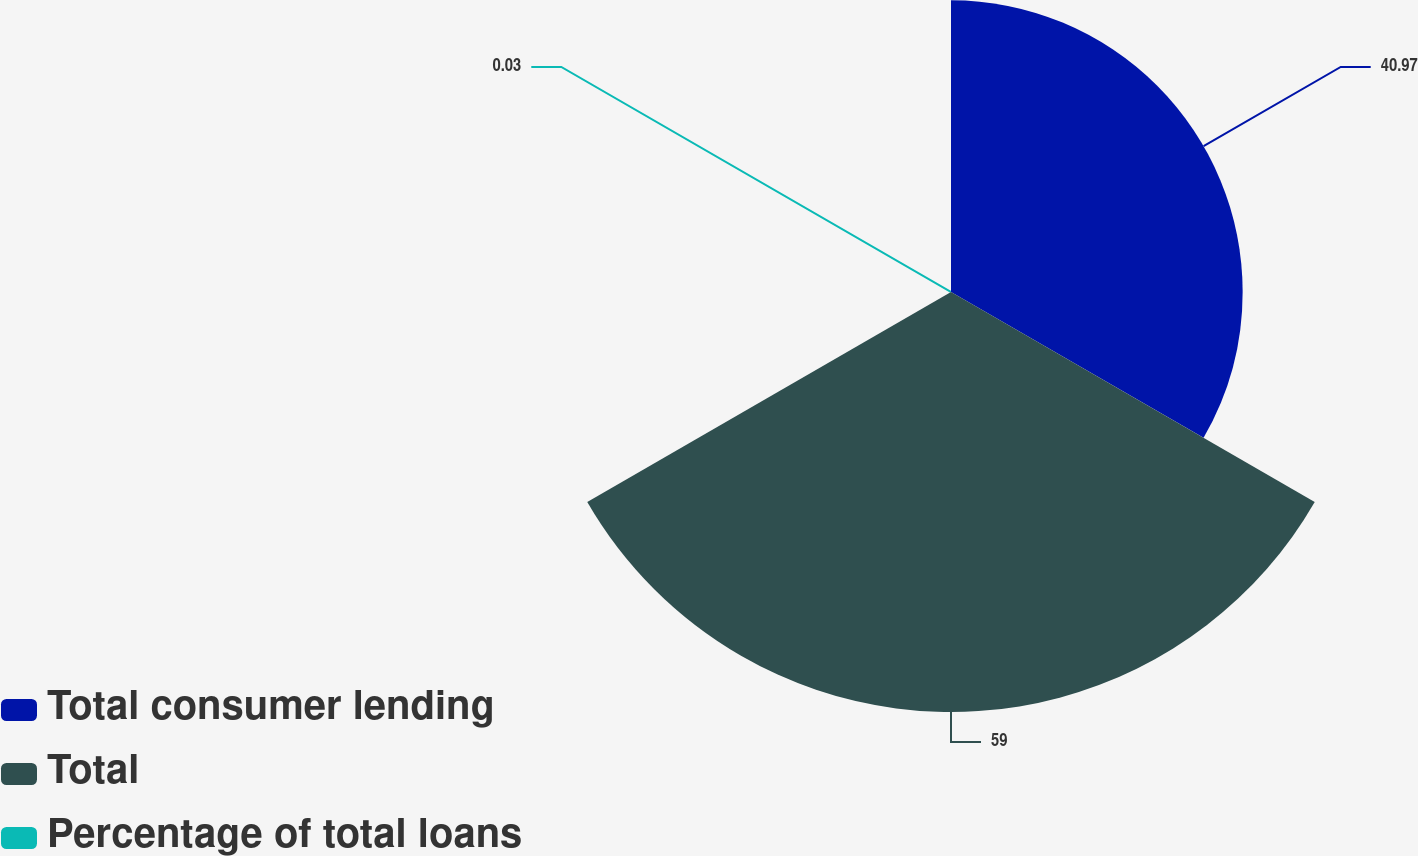Convert chart to OTSL. <chart><loc_0><loc_0><loc_500><loc_500><pie_chart><fcel>Total consumer lending<fcel>Total<fcel>Percentage of total loans<nl><fcel>40.97%<fcel>59.0%<fcel>0.03%<nl></chart> 